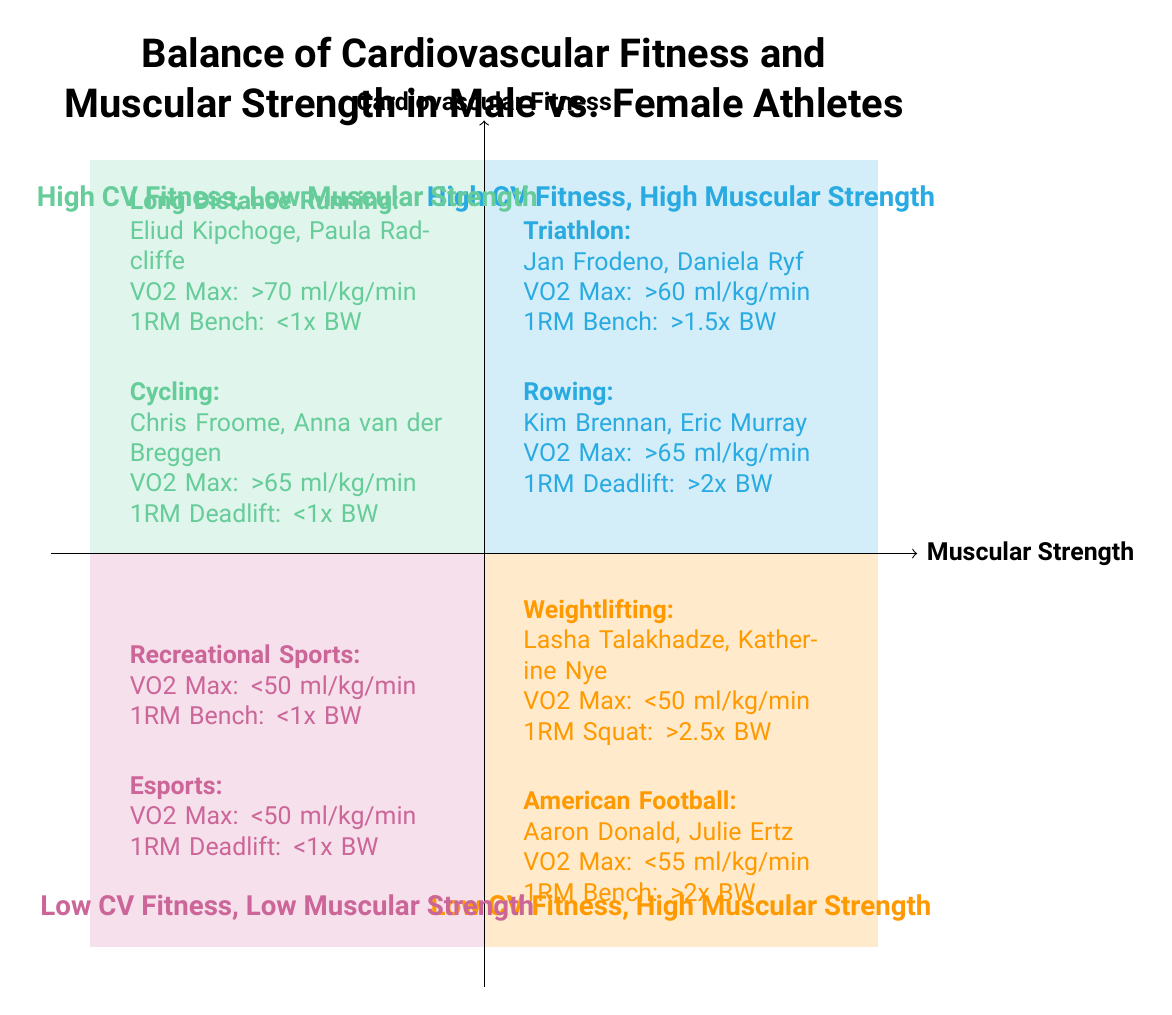What is the title of the diagram? The title is displayed at the top of the diagram, which summarizes the main focus of the chart: the balance of cardiovascular fitness and muscular strength in male vs. female athletes.
Answer: Balance of Cardiovascular Fitness and Muscular Strength in Male vs. Female Athletes Which quadrant contains athletes known for triathlon? The quadrant labeled "High Cardiovascular Fitness, High Muscular Strength" includes examples of athletes in triathlon, as indicated in the text within that section of the diagram.
Answer: High Cardiovascular Fitness, High Muscular Strength How many sports are represented in Quadrant 3? Quadrant 3 is labeled "Low Cardiovascular Fitness, High Muscular Strength" and includes two sports: Weightlifting and American Football, as seen in the examples listed.
Answer: 2 What is the key metric for 1RM Squat in Weightlifting? In Quadrant 3, the key metric for 1RM Squat is specified under the Weightlifting section, which indicates it is above 2.5 times body weight for example athletes.
Answer: Above 2.5x body weight What is the VO2 Max threshold for Long Distance Running athletes? In Quadrant 2, the VO2 Max threshold is listed for Long Distance Running, stating that it is above 70 ml/kg/min, which helps define the athletic performance in this category.
Answer: Above 70 ml/kg/min Which quadrant includes Recreational Sports? Recreational Sports are found in Quadrant 4, which is labeled "Low Cardiovascular Fitness, Low Muscular Strength," as shown in the examples in that quadrant.
Answer: Low Cardiovascular Fitness, Low Muscular Strength What type of athletes are represented in Quadrant 1? Quadrant 1 features athletes renowned for high performance in both cardiovascular fitness and muscular strength, including those from triathlon and rowing as specified in that quadrant's examples.
Answer: Triathlon and Rowing athletes What is the 1RM Bench Press requirement for athletes in Quadrant 2? Athletes in Quadrant 2, which includes Long Distance Running and Cycling, have a 1RM Bench Press requirement that is below 1 times body weight, as outlined in the key metrics.
Answer: Below 1x body weight 